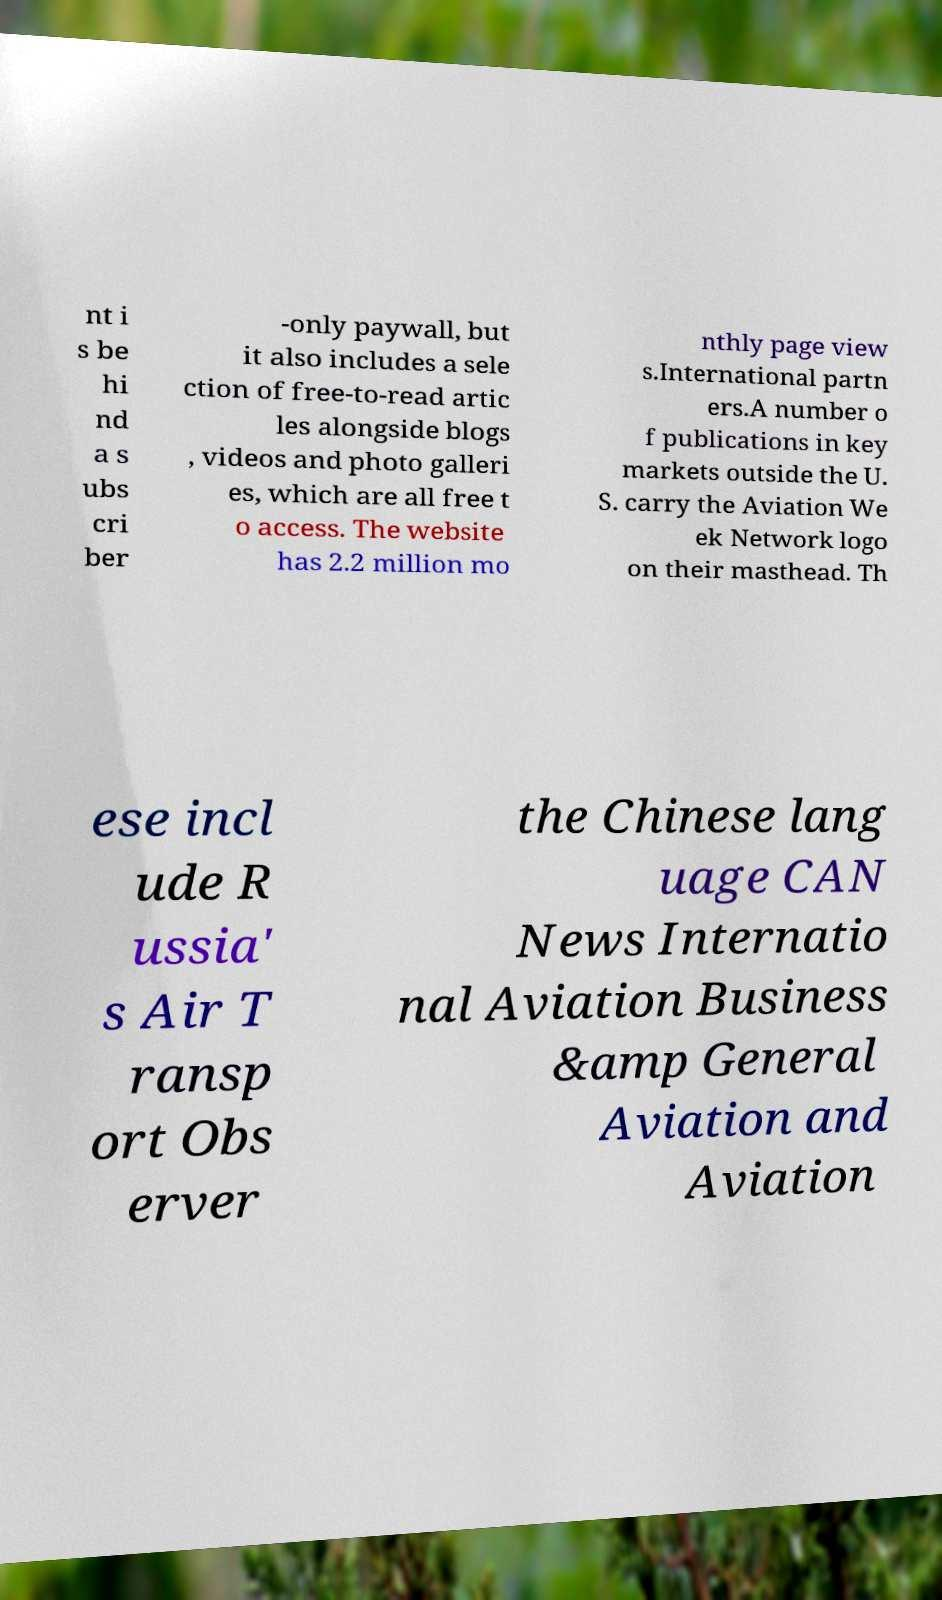Can you read and provide the text displayed in the image?This photo seems to have some interesting text. Can you extract and type it out for me? nt i s be hi nd a s ubs cri ber -only paywall, but it also includes a sele ction of free-to-read artic les alongside blogs , videos and photo galleri es, which are all free t o access. The website has 2.2 million mo nthly page view s.International partn ers.A number o f publications in key markets outside the U. S. carry the Aviation We ek Network logo on their masthead. Th ese incl ude R ussia' s Air T ransp ort Obs erver the Chinese lang uage CAN News Internatio nal Aviation Business &amp General Aviation and Aviation 